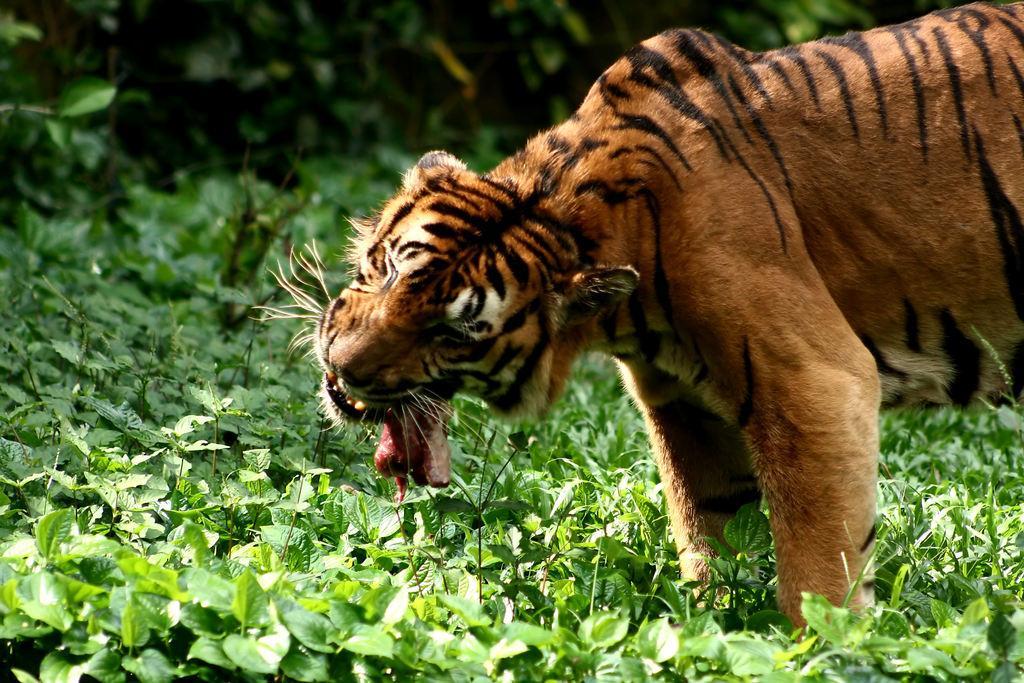How would you summarize this image in a sentence or two? In this image on the right side there is one tiger, and at the bottom there are some grass and plants. 